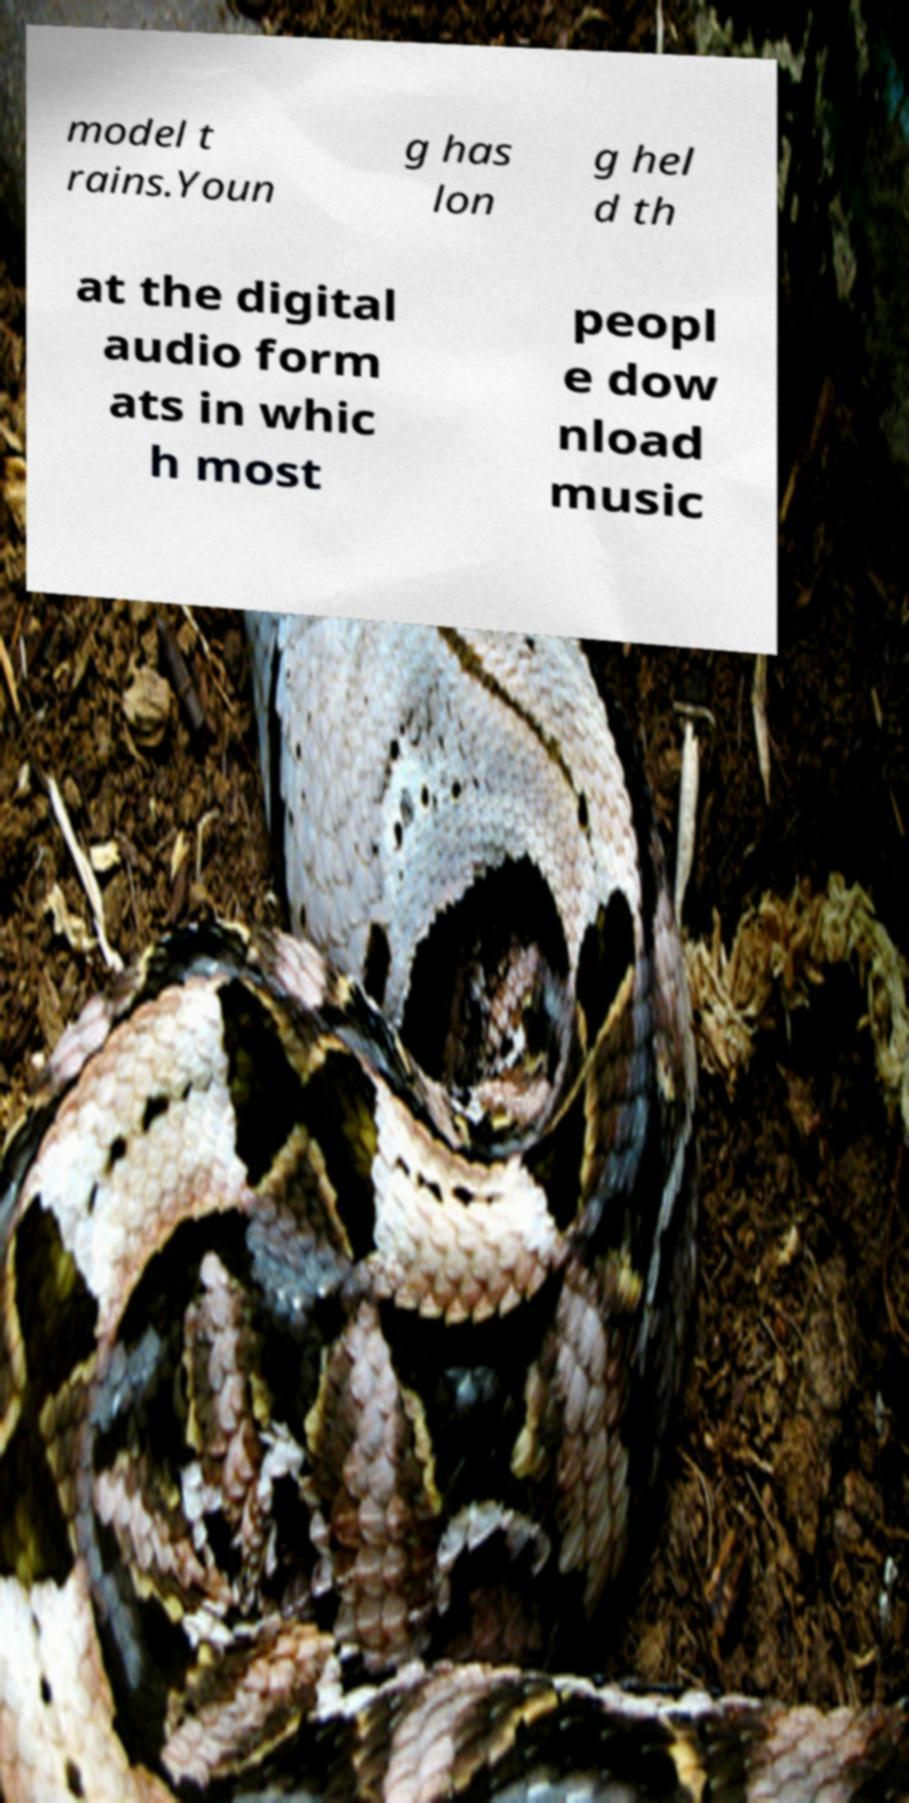For documentation purposes, I need the text within this image transcribed. Could you provide that? model t rains.Youn g has lon g hel d th at the digital audio form ats in whic h most peopl e dow nload music 